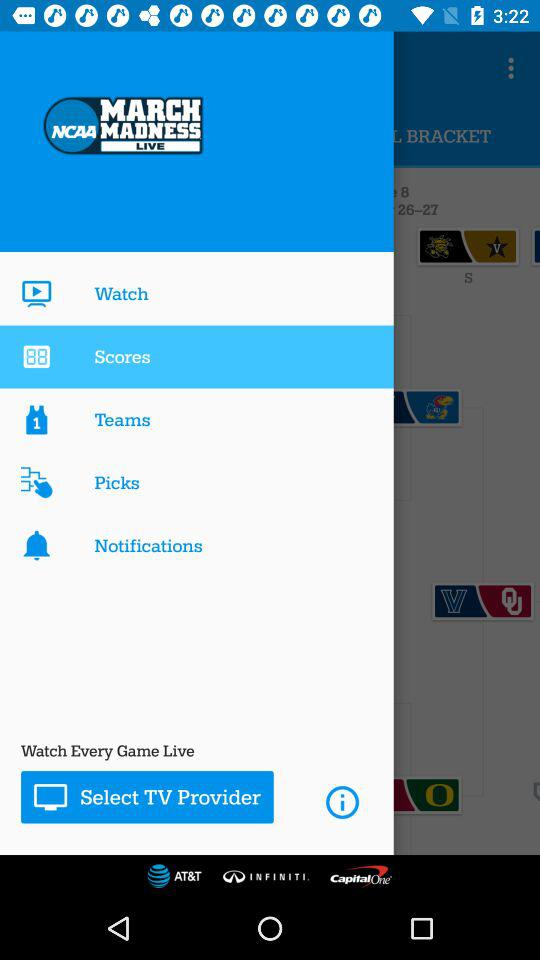Which is the selected item in the menu? The selected item in the menu is "Scores". 